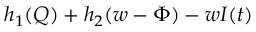<formula> <loc_0><loc_0><loc_500><loc_500>h _ { 1 } ( Q ) + h _ { 2 } ( w - \Phi ) - w I ( t )</formula> 